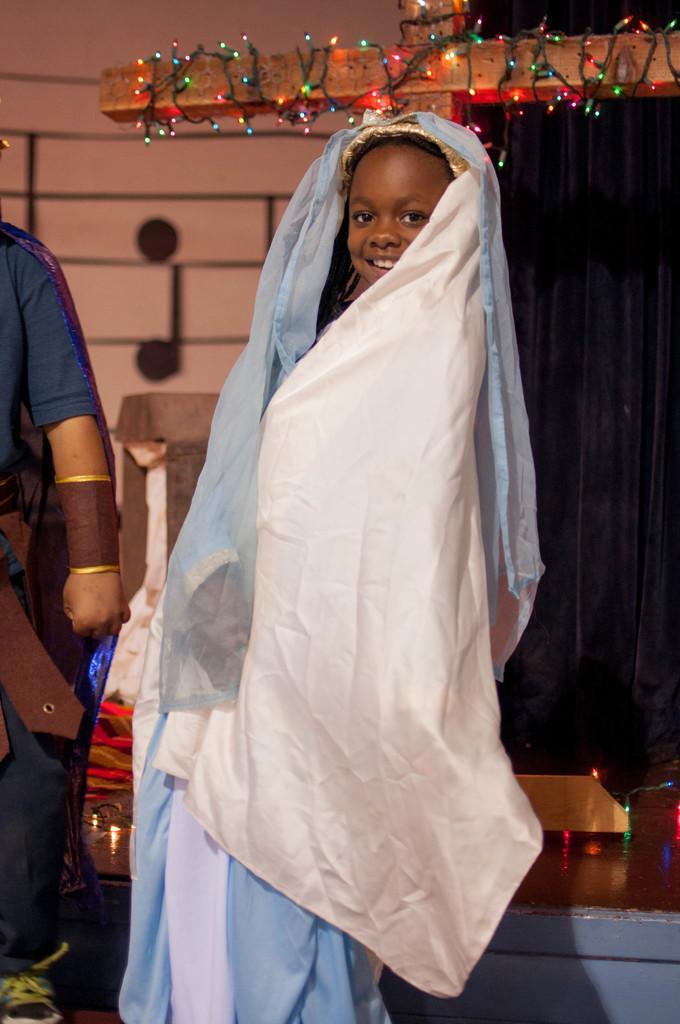Could you give a brief overview of what you see in this image? In this image I can see a person standing in the center of the image posing for the picture and wrapped in some clothes. I can see a wooden cross decorated with some lights. I can see another person standing towards the left hand side of the image. 